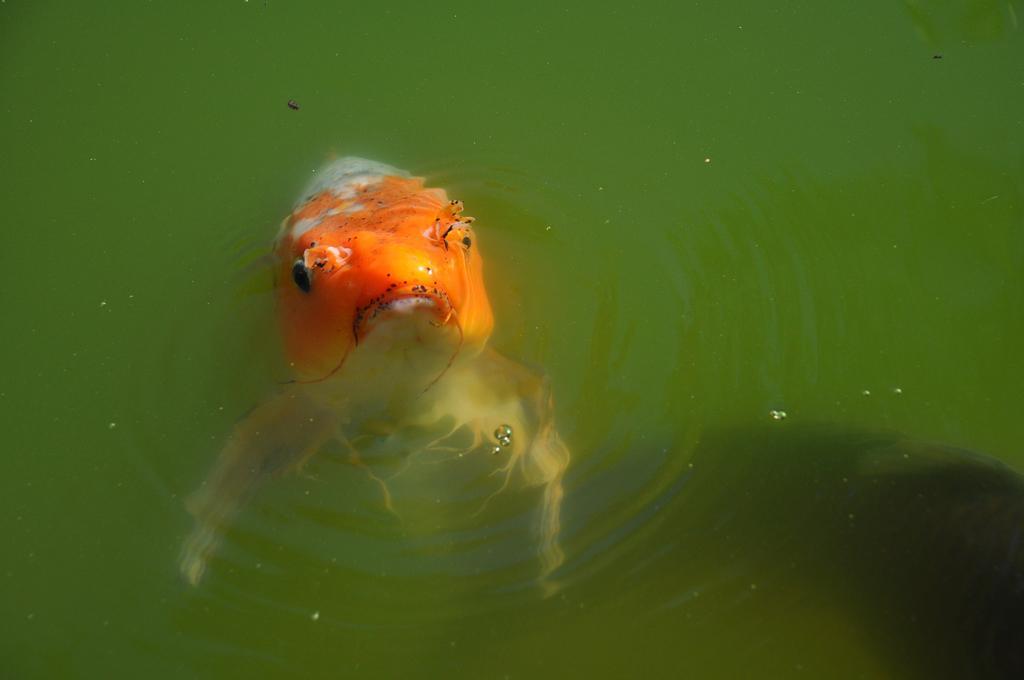In one or two sentences, can you explain what this image depicts? In this image we can see there is a fish in the water. 